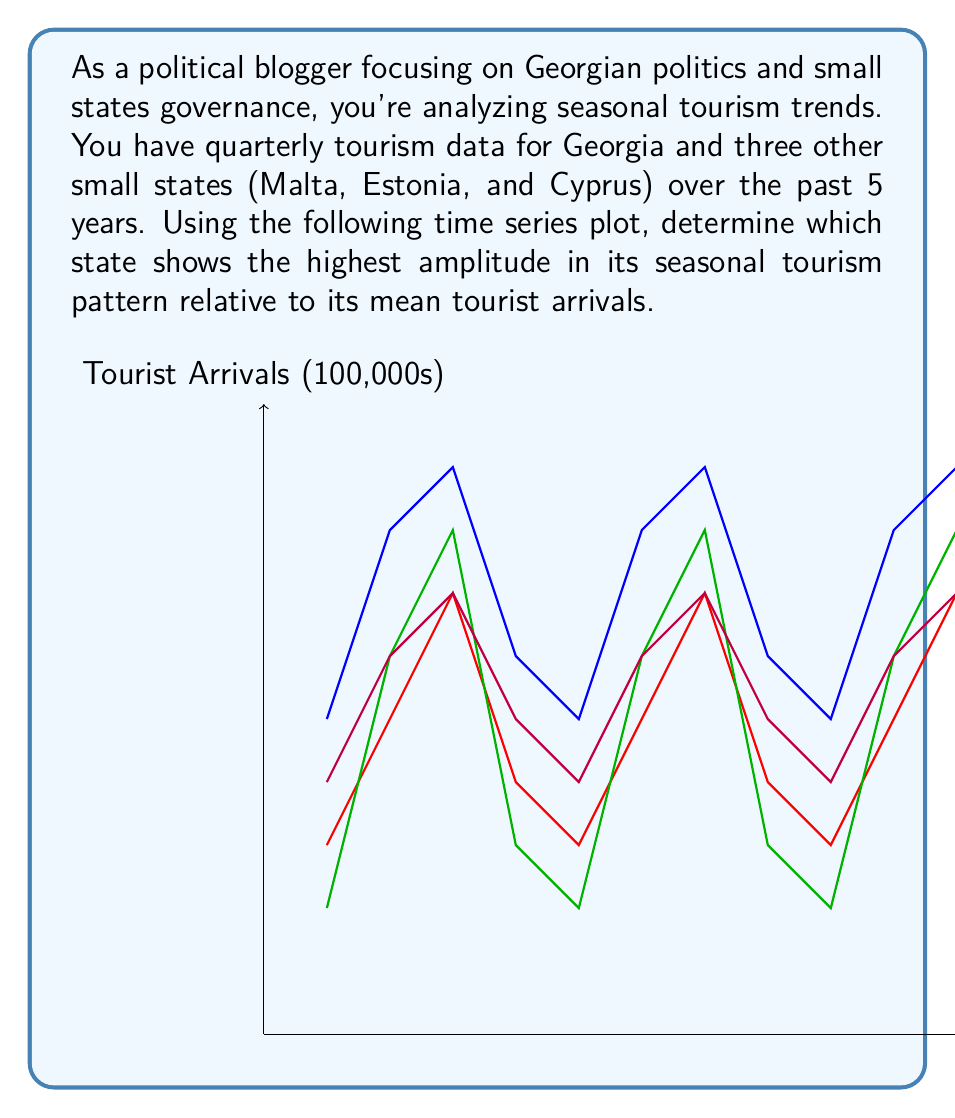Give your solution to this math problem. To determine which state shows the highest amplitude in its seasonal tourism pattern relative to its mean tourist arrivals, we need to follow these steps:

1) Calculate the mean tourist arrivals for each state:

   Georgia: $\bar{x}_G = \frac{1}{20}\sum_{i=1}^{20} x_i = 7$
   Malta: $\bar{x}_M = \frac{1}{20}\sum_{i=1}^{20} x_i = 4.5$
   Estonia: $\bar{x}_E = \frac{1}{20}\sum_{i=1}^{20} x_i = 4.75$
   Cyprus: $\bar{x}_C = \frac{1}{20}\sum_{i=1}^{20} x_i = 5.5$

2) Find the amplitude (difference between maximum and minimum values) for each state:

   Georgia: $A_G = 9 - 5 = 4$
   Malta: $A_M = 7 - 3 = 4$
   Estonia: $A_E = 8 - 2 = 6$
   Cyprus: $A_C = 7 - 4 = 3$

3) Calculate the relative amplitude by dividing the amplitude by the mean:

   Georgia: $RA_G = \frac{A_G}{\bar{x}_G} = \frac{4}{7} \approx 0.571$
   Malta: $RA_M = \frac{A_M}{\bar{x}_M} = \frac{4}{4.5} \approx 0.889$
   Estonia: $RA_E = \frac{A_E}{\bar{x}_E} = \frac{6}{4.75} \approx 1.263$
   Cyprus: $RA_C = \frac{A_C}{\bar{x}_C} = \frac{3}{5.5} \approx 0.545$

4) Compare the relative amplitudes. The highest value indicates the state with the highest amplitude relative to its mean tourist arrivals.
Answer: Estonia (relative amplitude ≈ 1.263) 